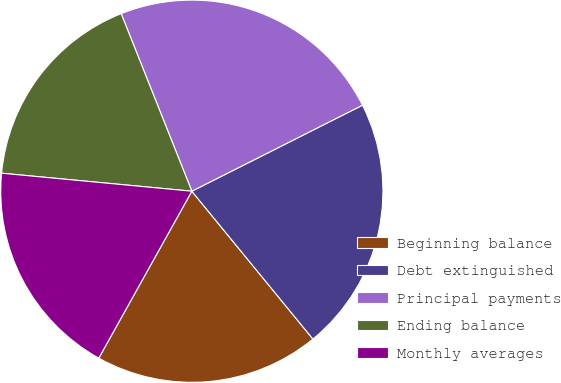Convert chart. <chart><loc_0><loc_0><loc_500><loc_500><pie_chart><fcel>Beginning balance<fcel>Debt extinguished<fcel>Principal payments<fcel>Ending balance<fcel>Monthly averages<nl><fcel>19.02%<fcel>21.51%<fcel>23.6%<fcel>17.47%<fcel>18.41%<nl></chart> 